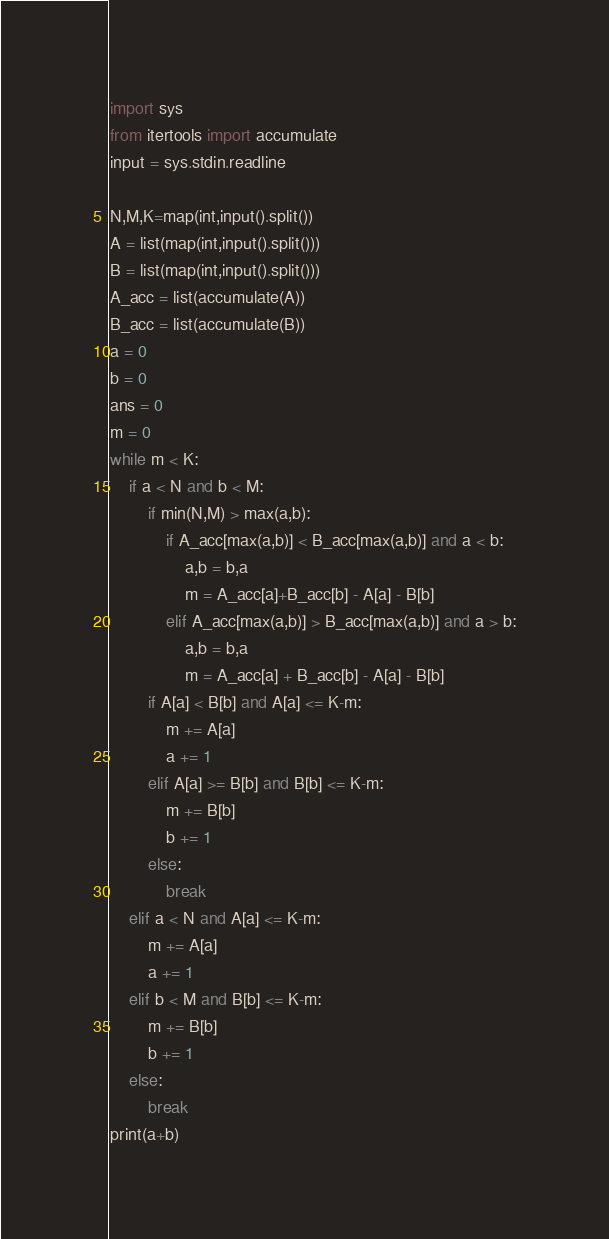<code> <loc_0><loc_0><loc_500><loc_500><_Python_>import sys
from itertools import accumulate
input = sys.stdin.readline

N,M,K=map(int,input().split())
A = list(map(int,input().split()))
B = list(map(int,input().split()))
A_acc = list(accumulate(A))
B_acc = list(accumulate(B))
a = 0
b = 0
ans = 0
m = 0
while m < K:
    if a < N and b < M:
        if min(N,M) > max(a,b):
            if A_acc[max(a,b)] < B_acc[max(a,b)] and a < b:
                a,b = b,a
                m = A_acc[a]+B_acc[b] - A[a] - B[b]
            elif A_acc[max(a,b)] > B_acc[max(a,b)] and a > b:
                a,b = b,a
                m = A_acc[a] + B_acc[b] - A[a] - B[b]
        if A[a] < B[b] and A[a] <= K-m:
            m += A[a]
            a += 1
        elif A[a] >= B[b] and B[b] <= K-m:
            m += B[b]
            b += 1
        else:
            break
    elif a < N and A[a] <= K-m:
        m += A[a]
        a += 1
    elif b < M and B[b] <= K-m:
        m += B[b]
        b += 1
    else:
        break
print(a+b)</code> 